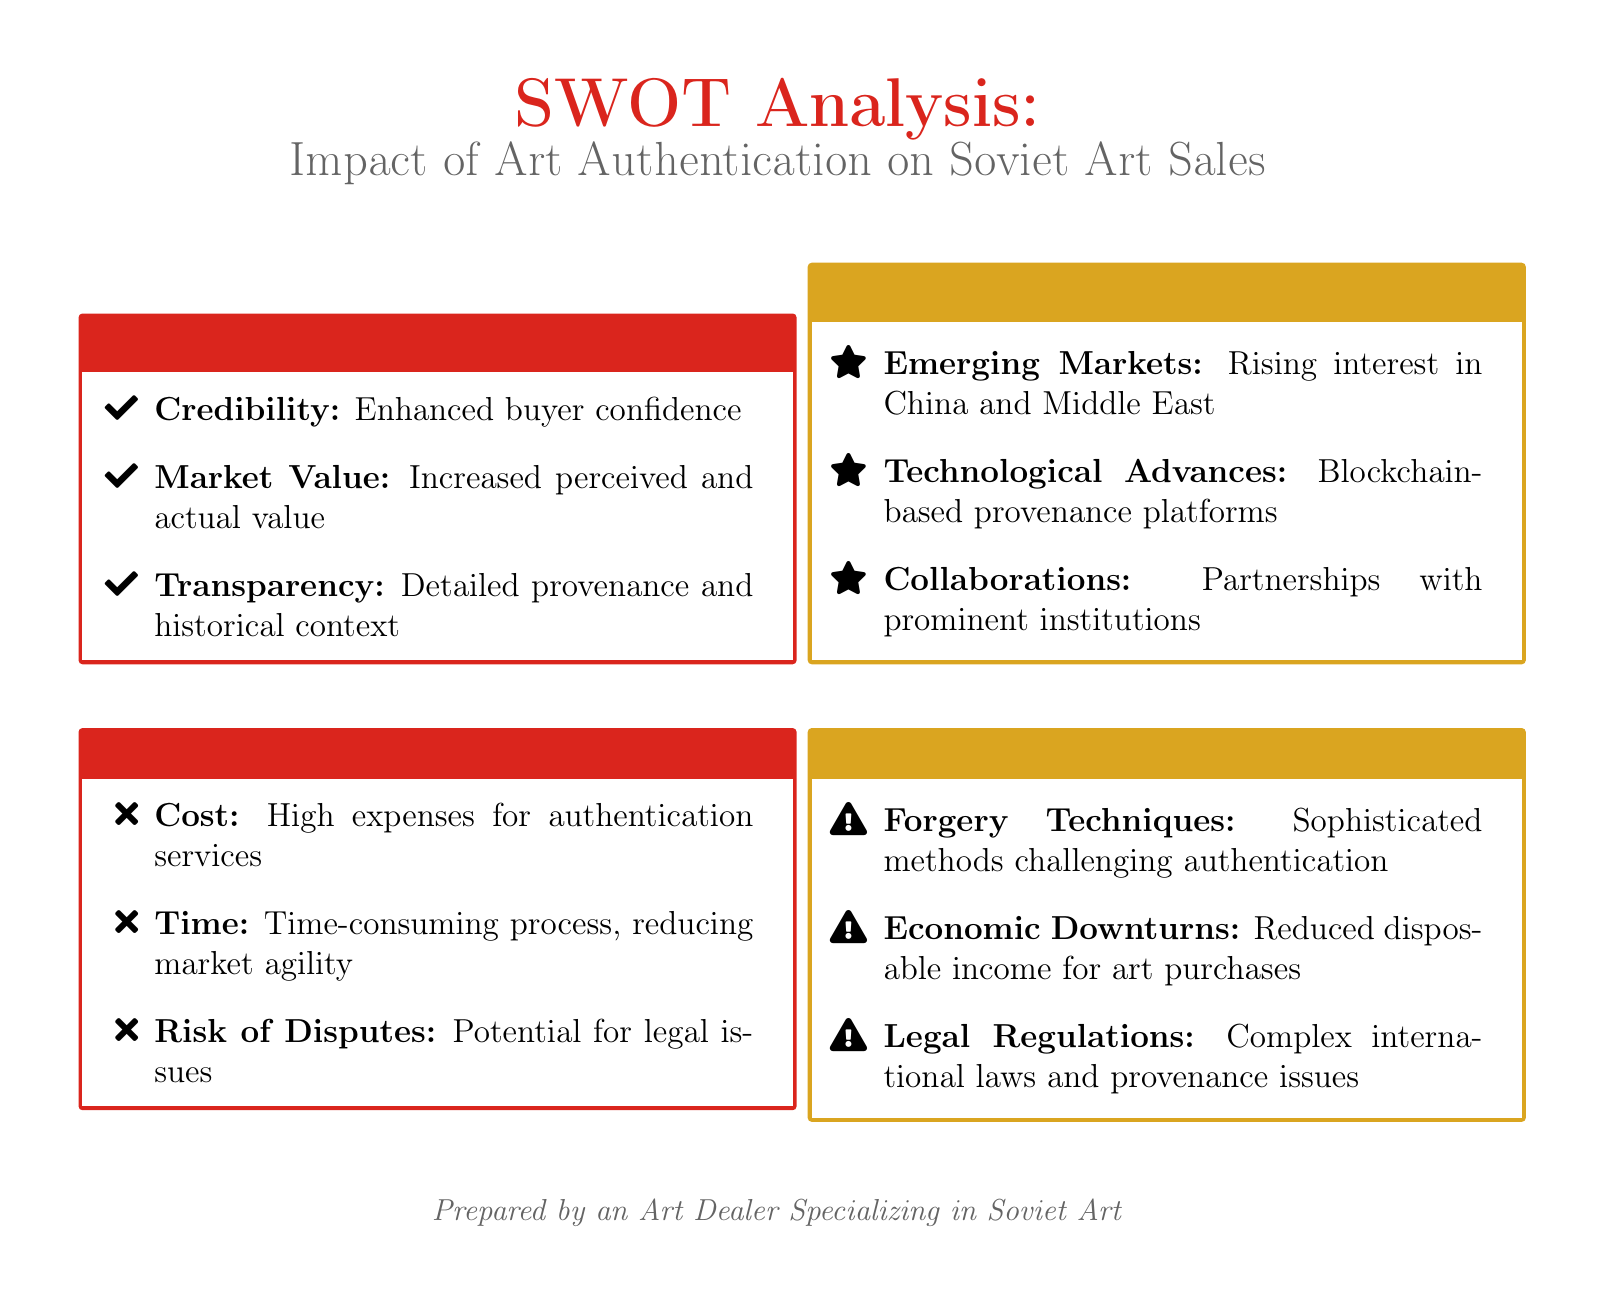What are the strengths listed in the SWOT analysis? The strengths include credibility, market value, and transparency as highlighted in the document.
Answer: Credibility, Market Value, Transparency What is a weakness regarding the cost of art authentication services? The document states that high expenses for authentication services are a notable weakness.
Answer: High expenses What opportunity involves technological advances? The document mentions blockchain-based provenance platforms as an opportunity arising from technological advances.
Answer: Blockchain-based provenance platforms How many weaknesses are identified in total? There are three weaknesses listed in the document under the weaknesses section of the SWOT analysis.
Answer: Three What threat is associated with economic factors? The document identifies economic downturns as a threat that may reduce disposable income for art purchases.
Answer: Economic downturns What aspect of the market is highlighted as an opportunity within emerging markets? The document highlights rising interest in China and the Middle East as a part of the opportunities in emerging markets.
Answer: Rising interest in China and Middle East What is the primary document type of the analysis presented? The document presents a SWOT analysis that evaluates various aspects of art authentication services.
Answer: SWOT analysis What is the main legal concern mentioned in the threats section? The threats section notes complex international laws and provenance issues as a primary legal concern.
Answer: Complex international laws and provenance issues 